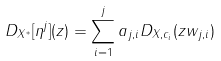Convert formula to latex. <formula><loc_0><loc_0><loc_500><loc_500>D _ { X ^ { * } } [ \eta ^ { j } ] ( z ) = \sum _ { i = 1 } ^ { j } a _ { j , i } D _ { X , c _ { i } } ( z w _ { j , i } )</formula> 